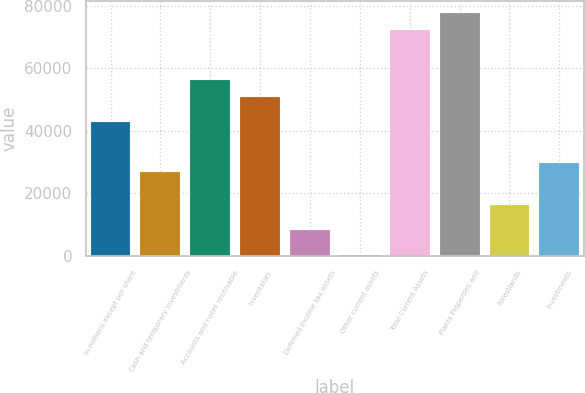Convert chart to OTSL. <chart><loc_0><loc_0><loc_500><loc_500><bar_chart><fcel>In millions except per share<fcel>Cash and temporary investments<fcel>Accounts and notes receivable<fcel>Inventories<fcel>Deferred income tax assets<fcel>Other current assets<fcel>Total Current Assets<fcel>Plants Properties and<fcel>Forestlands<fcel>Investments<nl><fcel>42957.6<fcel>26913<fcel>56328.1<fcel>50979.9<fcel>8194.3<fcel>172<fcel>72372.7<fcel>77720.9<fcel>16216.6<fcel>29587.1<nl></chart> 